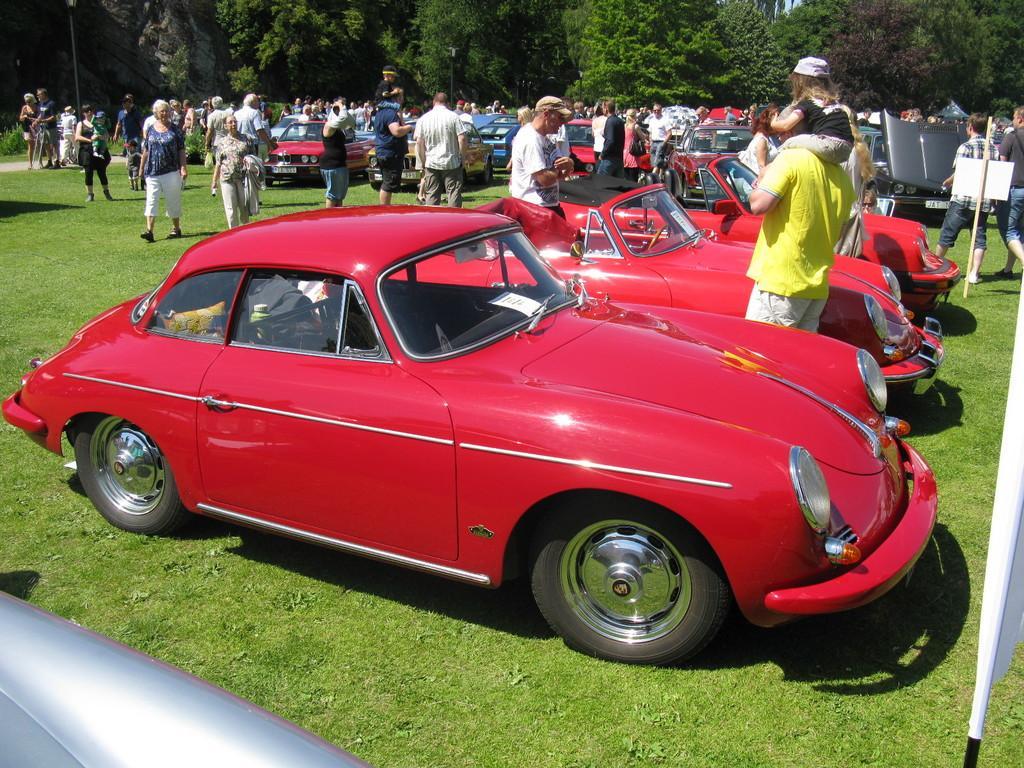Please provide a concise description of this image. In this image, there is grass on the ground which is in green color, there are some red color cars, there are some people looking the cars, there are some people walking at the left, at the background there are some green color trees. 